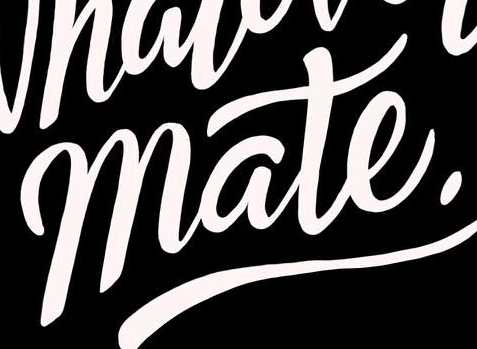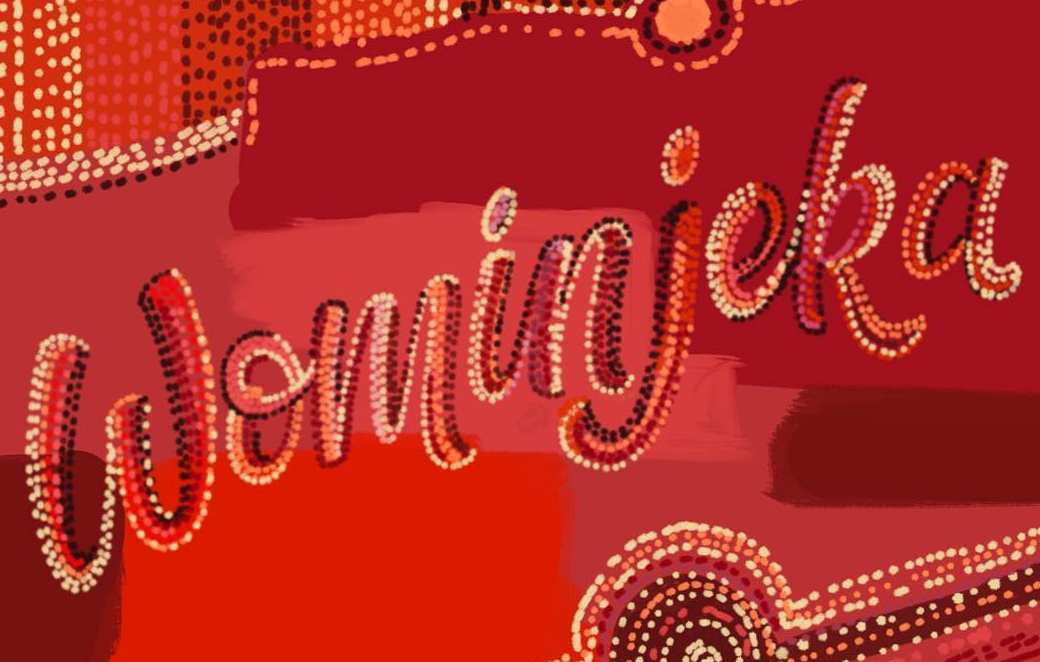What words can you see in these images in sequence, separated by a semicolon? mate.; Wominjeka 